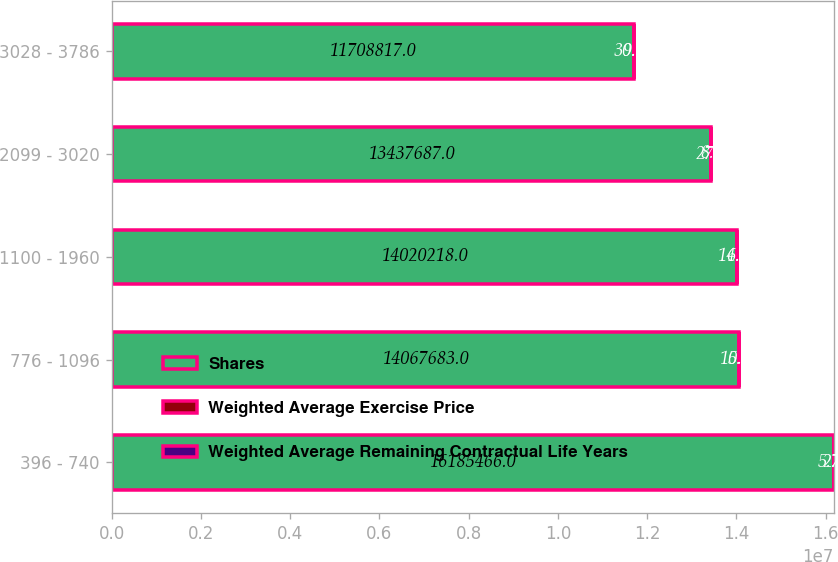Convert chart to OTSL. <chart><loc_0><loc_0><loc_500><loc_500><stacked_bar_chart><ecel><fcel>396 - 740<fcel>776 - 1096<fcel>1100 - 1960<fcel>2099 - 3020<fcel>3028 - 3786<nl><fcel>Shares<fcel>1.61855e+07<fcel>1.40677e+07<fcel>1.40202e+07<fcel>1.34377e+07<fcel>1.17088e+07<nl><fcel>Weighted Average Exercise Price<fcel>2.7<fcel>5.3<fcel>6.9<fcel>8.2<fcel>9.1<nl><fcel>Weighted Average Remaining Contractual Life Years<fcel>5.76<fcel>10.25<fcel>14.92<fcel>27<fcel>30.67<nl></chart> 